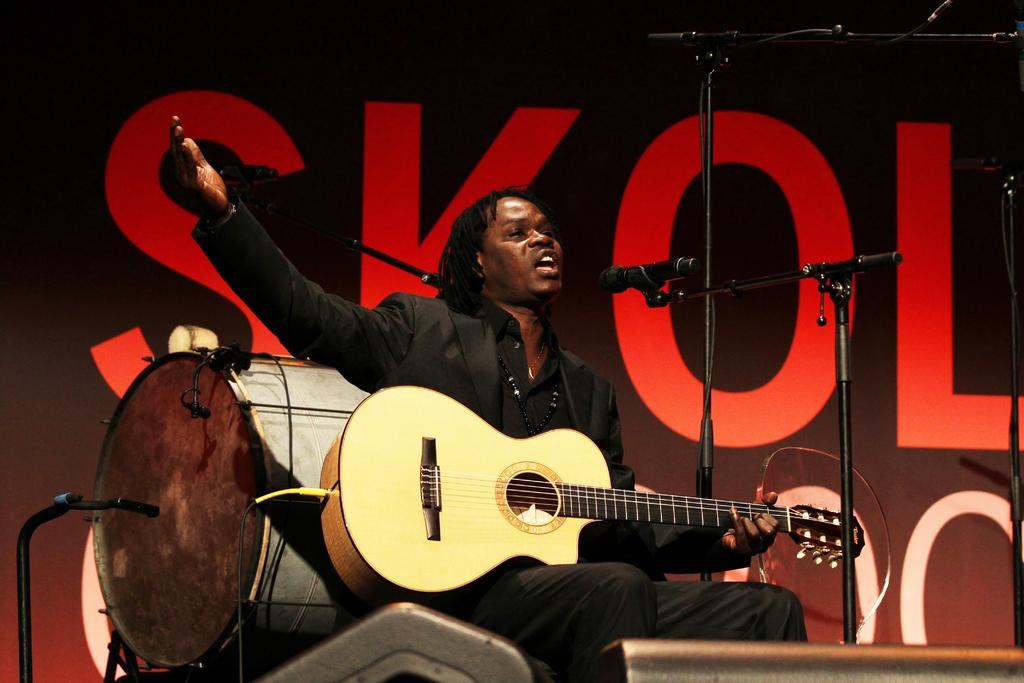What is the man in the image doing? The man is sitting and singing into a microphone. What instrument is the man holding? The man is holding a guitar. What is located behind the man? There is a drum behind the man. What can be seen at the top of the image? There is a banner at the top of the image. What type of toothpaste is the man using in the image? There is no toothpaste present in the image. How much salt is visible on the drum in the image? There is no salt visible on the drum in the image. 